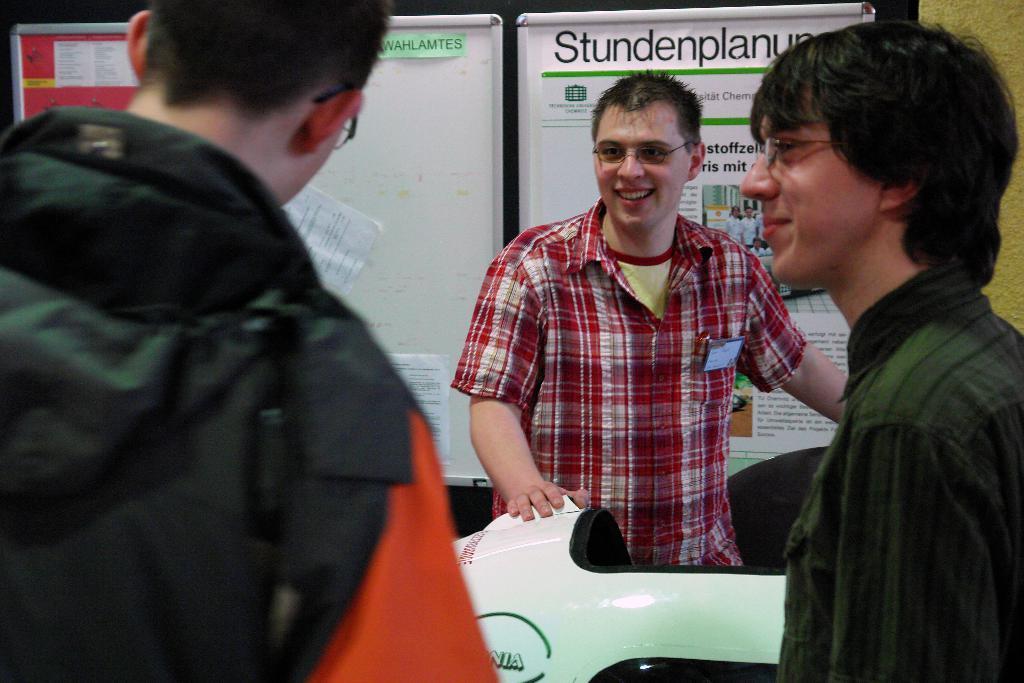Could you give a brief overview of what you see in this image? In this image I can see few people and they are wearing different dress. Back I can see two white boards and one red board. In front I can see a white and black color object. 